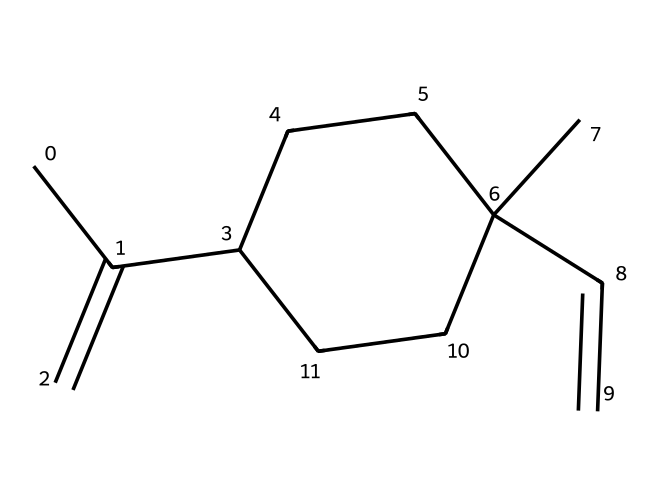How many carbon atoms are present in limonene? By analyzing the provided SMILES structure, we count all the 'C' symbols. In total, there are 10 carbon atoms.
Answer: 10 What type of chemical bond is primarily present in the limonene structure? In the SMILES representation, there are double bonds indicated by the '=' signs, along with many single bonds. Limonene primarily possesses carbon-carbon single bonds along with a few double bonds.
Answer: single and double Is limonene a chiral compound? A compound is chiral if it has at least one carbon atom bonded to four different substituents. Examining the structure, one carbon atom fits this criterion, confirming its chirality.
Answer: yes How many double bonds exist in limonene? Looking at the SMILES notation, we recognize the '=' signs representing double bonds. There are two such occurrences, which indicates two double bonds in the structure.
Answer: 2 What kind of functional group is characteristic of limonene? In the SMILES structure, the absence of oxygen or nitrogen atoms suggests that limonene is primarily a hydrocarbon. It indicates the presence of alkenes due to the double bonds, a common characteristic in limonene.
Answer: alkene What is the molecular formula for limonene? By counting the elements from the SMILES structure, we can derive the molecular formula. There are 10 carbon atoms, 16 hydrogen atoms, and no other elements, resulting in a formula of C10H16.
Answer: C10H16 